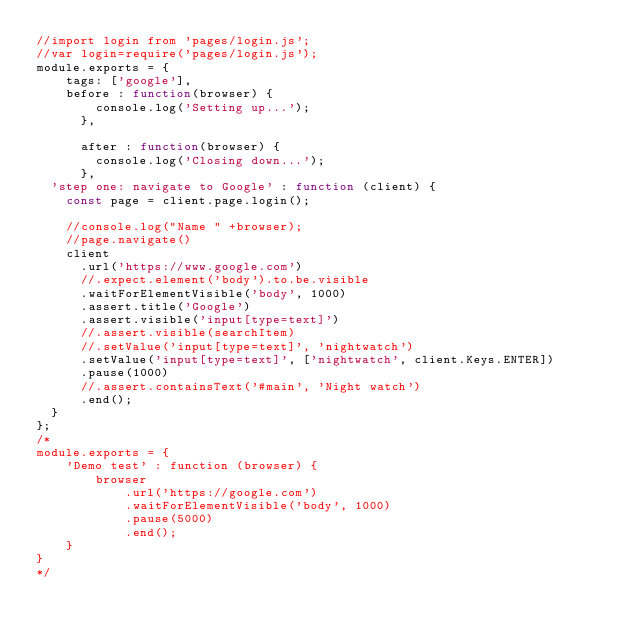Convert code to text. <code><loc_0><loc_0><loc_500><loc_500><_JavaScript_>//import login from 'pages/login.js';
//var login=require('pages/login.js');
module.exports = {
    tags: ['google'],
    before : function(browser) {
        console.log('Setting up...');
      },
    
      after : function(browser) {
        console.log('Closing down...');
      },
  'step one: navigate to Google' : function (client) {
    const page = client.page.login();

    //console.log("Name " +browser);
    //page.navigate()
    client
      .url('https://www.google.com')
      //.expect.element('body').to.be.visible
      .waitForElementVisible('body', 1000)
      .assert.title('Google')
      .assert.visible('input[type=text]')
      //.assert.visible(searchItem)
      //.setValue('input[type=text]', 'nightwatch')
      .setValue('input[type=text]', ['nightwatch', client.Keys.ENTER])
      .pause(1000)
      //.assert.containsText('#main', 'Night watch')
      .end();
  }  
};
/*
module.exports = {
    'Demo test' : function (browser) {
        browser
            .url('https://google.com')
            .waitForElementVisible('body', 1000)
            .pause(5000)
            .end();
    }
}
*/</code> 